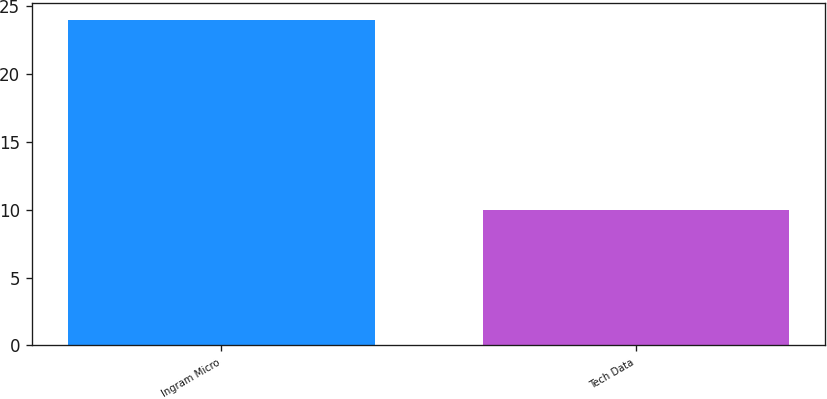<chart> <loc_0><loc_0><loc_500><loc_500><bar_chart><fcel>Ingram Micro<fcel>Tech Data<nl><fcel>24<fcel>10<nl></chart> 